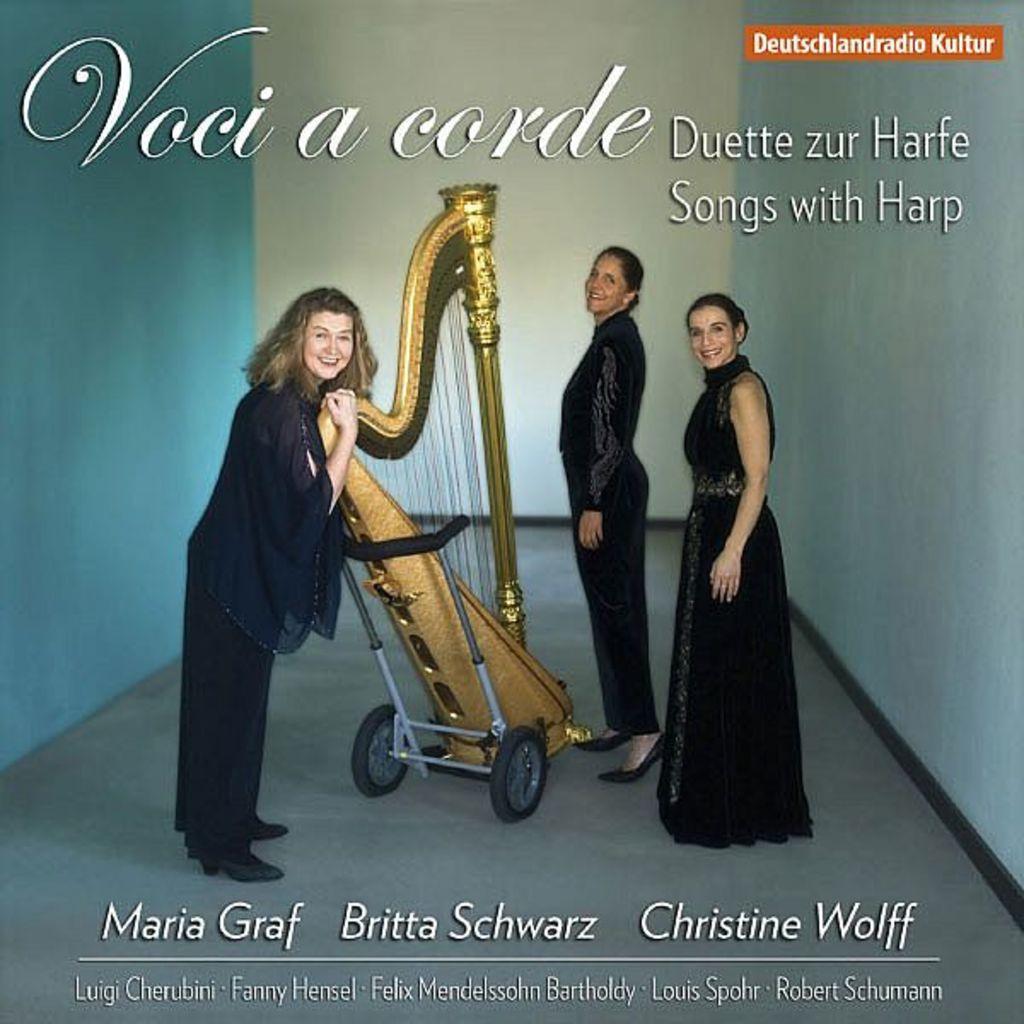How would you summarize this image in a sentence or two? In the center of the image, we can see a musical instrument on the trolley and there are some people. In the background, there is a wall and we can see some text. 